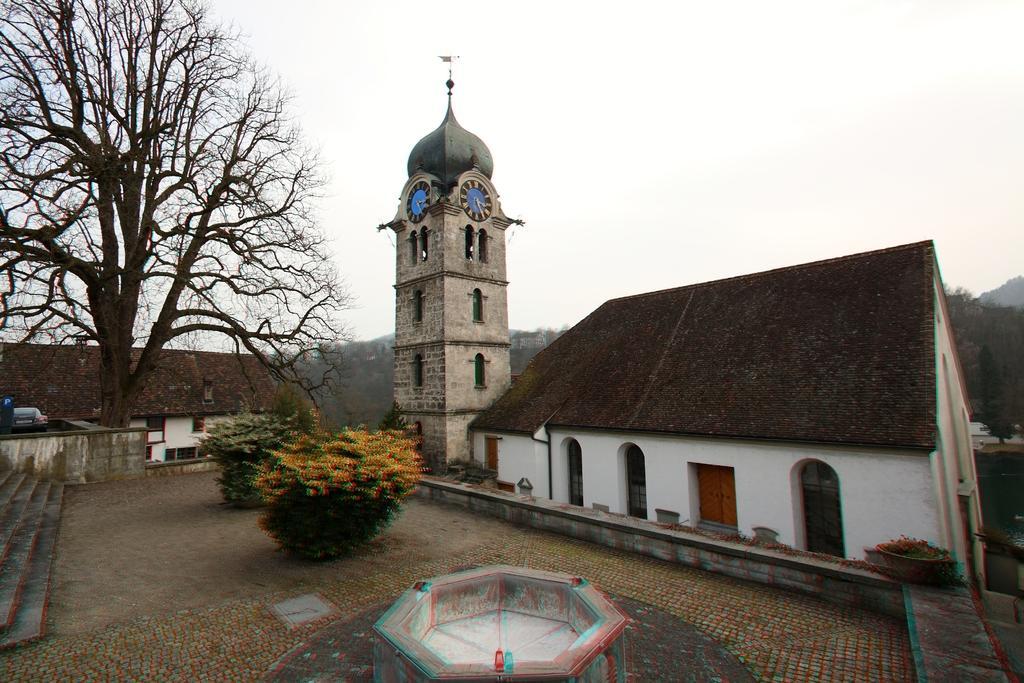How would you summarize this image in a sentence or two? In this picture we can see few houses and clocks on the tower, in front of the house we can find few shrubs, trees and a vehicle. 